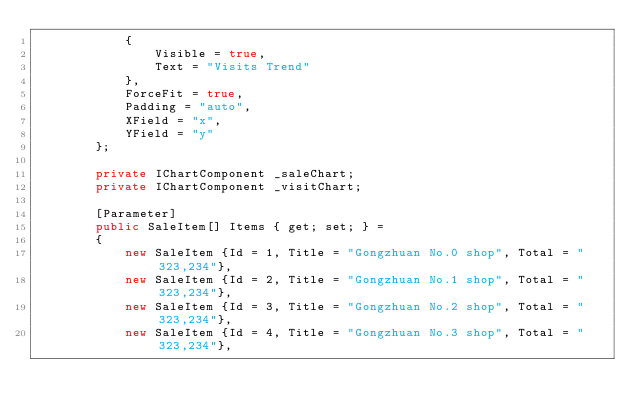Convert code to text. <code><loc_0><loc_0><loc_500><loc_500><_C#_>            {
                Visible = true,
                Text = "Visits Trend"
            },
            ForceFit = true,
            Padding = "auto",
            XField = "x",
            YField = "y"
        };

        private IChartComponent _saleChart;
        private IChartComponent _visitChart;

        [Parameter]
        public SaleItem[] Items { get; set; } =
        {
            new SaleItem {Id = 1, Title = "Gongzhuan No.0 shop", Total = "323,234"},
            new SaleItem {Id = 2, Title = "Gongzhuan No.1 shop", Total = "323,234"},
            new SaleItem {Id = 3, Title = "Gongzhuan No.2 shop", Total = "323,234"},
            new SaleItem {Id = 4, Title = "Gongzhuan No.3 shop", Total = "323,234"},</code> 